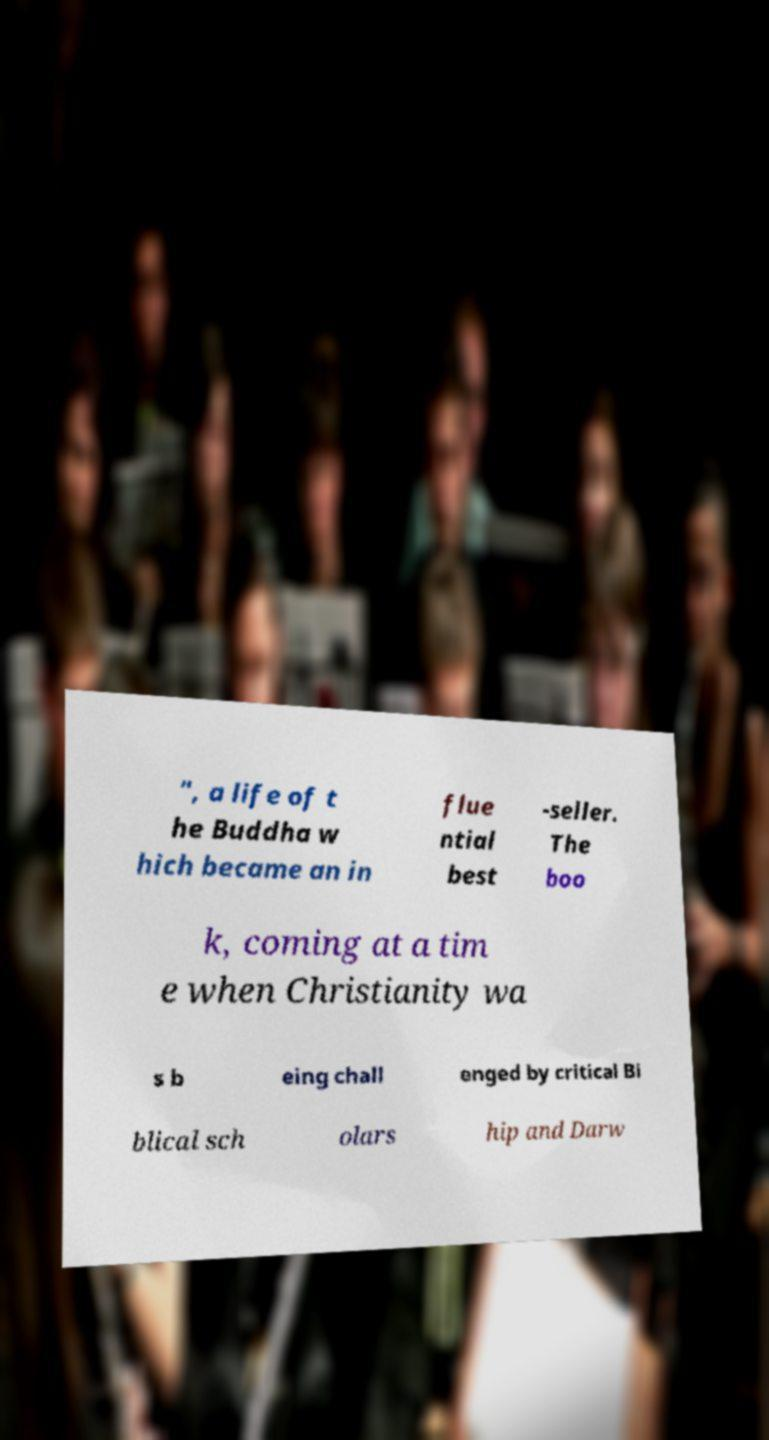For documentation purposes, I need the text within this image transcribed. Could you provide that? ", a life of t he Buddha w hich became an in flue ntial best -seller. The boo k, coming at a tim e when Christianity wa s b eing chall enged by critical Bi blical sch olars hip and Darw 